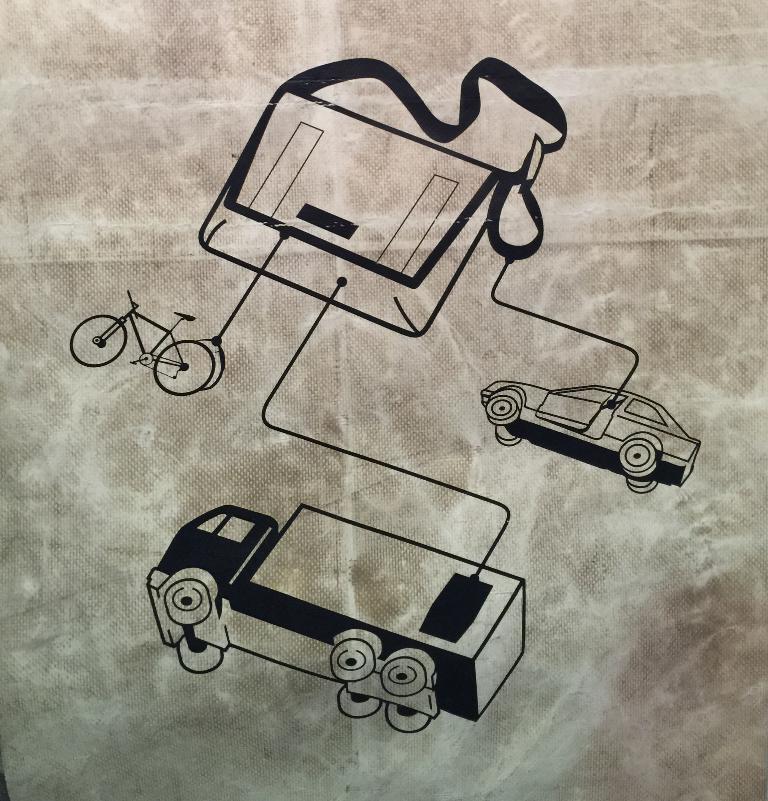How would you summarize this image in a sentence or two? Here I can see a sketch of two vehicles, a bag and a bicycle. 